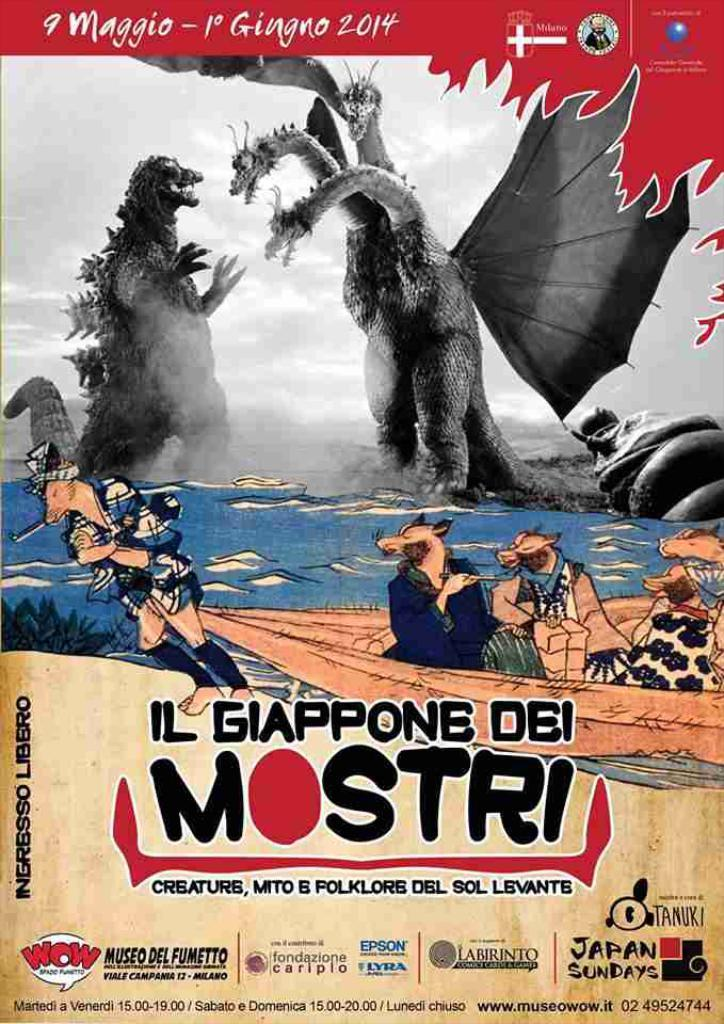<image>
Provide a brief description of the given image. A poster of a monster fighting a three headed dragon with the word Mostri written on it. 